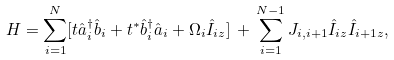Convert formula to latex. <formula><loc_0><loc_0><loc_500><loc_500>H = \sum _ { i = 1 } ^ { N } [ t \hat { a } _ { i } ^ { \dagger } \hat { b } _ { i } + t ^ { * } \hat { b } _ { i } ^ { \dagger } \hat { a } _ { i } + \Omega _ { i } \hat { I } _ { i z } ] \, + \, \sum _ { i = 1 } ^ { N - 1 } J _ { i , i + 1 } \hat { I } _ { i z } \hat { I } _ { i + 1 z } ,</formula> 